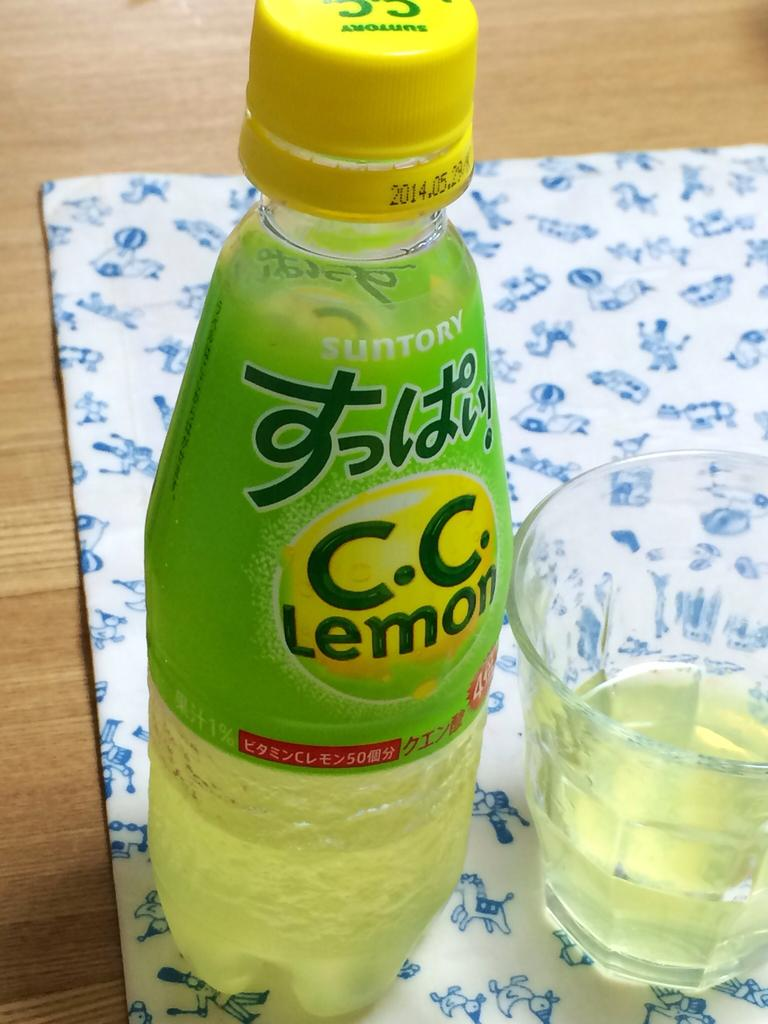<image>
Provide a brief description of the given image. A bottle of C.C. Lemon with a green label and yellow cap. 